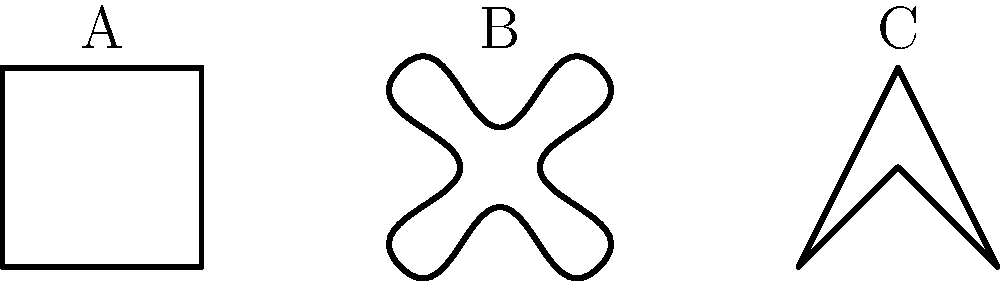Consider the three traditional textile patterns shown above, labeled A, B, and C. Which of these patterns is topologically equivalent to a torus? To determine which pattern is topologically equivalent to a torus, we need to analyze the topological properties of each pattern:

1. Pattern A:
   - This is a simple square shape with no holes.
   - Topologically, it is equivalent to a disc or a sphere.

2. Pattern B:
   - This pattern has a complex curved boundary but no holes.
   - Like Pattern A, it is topologically equivalent to a disc or a sphere.

3. Pattern C:
   - This pattern has a central hole created by the intersecting lines.
   - The presence of a single hole makes it topologically equivalent to a torus.

A torus is a surface of genus 1, meaning it has one hole. In textile patterns, this can be represented by a central opening or a pattern that, when repeated, creates a continuous hole.

Pattern C, with its central opening, can be deformed continuously into a torus shape without tearing or gluing. If you imagine this pattern repeated infinitely in all directions on a plane, it would create a lattice of holes that is topologically equivalent to the surface of a torus.

In contrast, Patterns A and B have no holes and are topologically equivalent to a sphere, which has genus 0.

Therefore, among the given patterns, only Pattern C is topologically equivalent to a torus.
Answer: Pattern C 